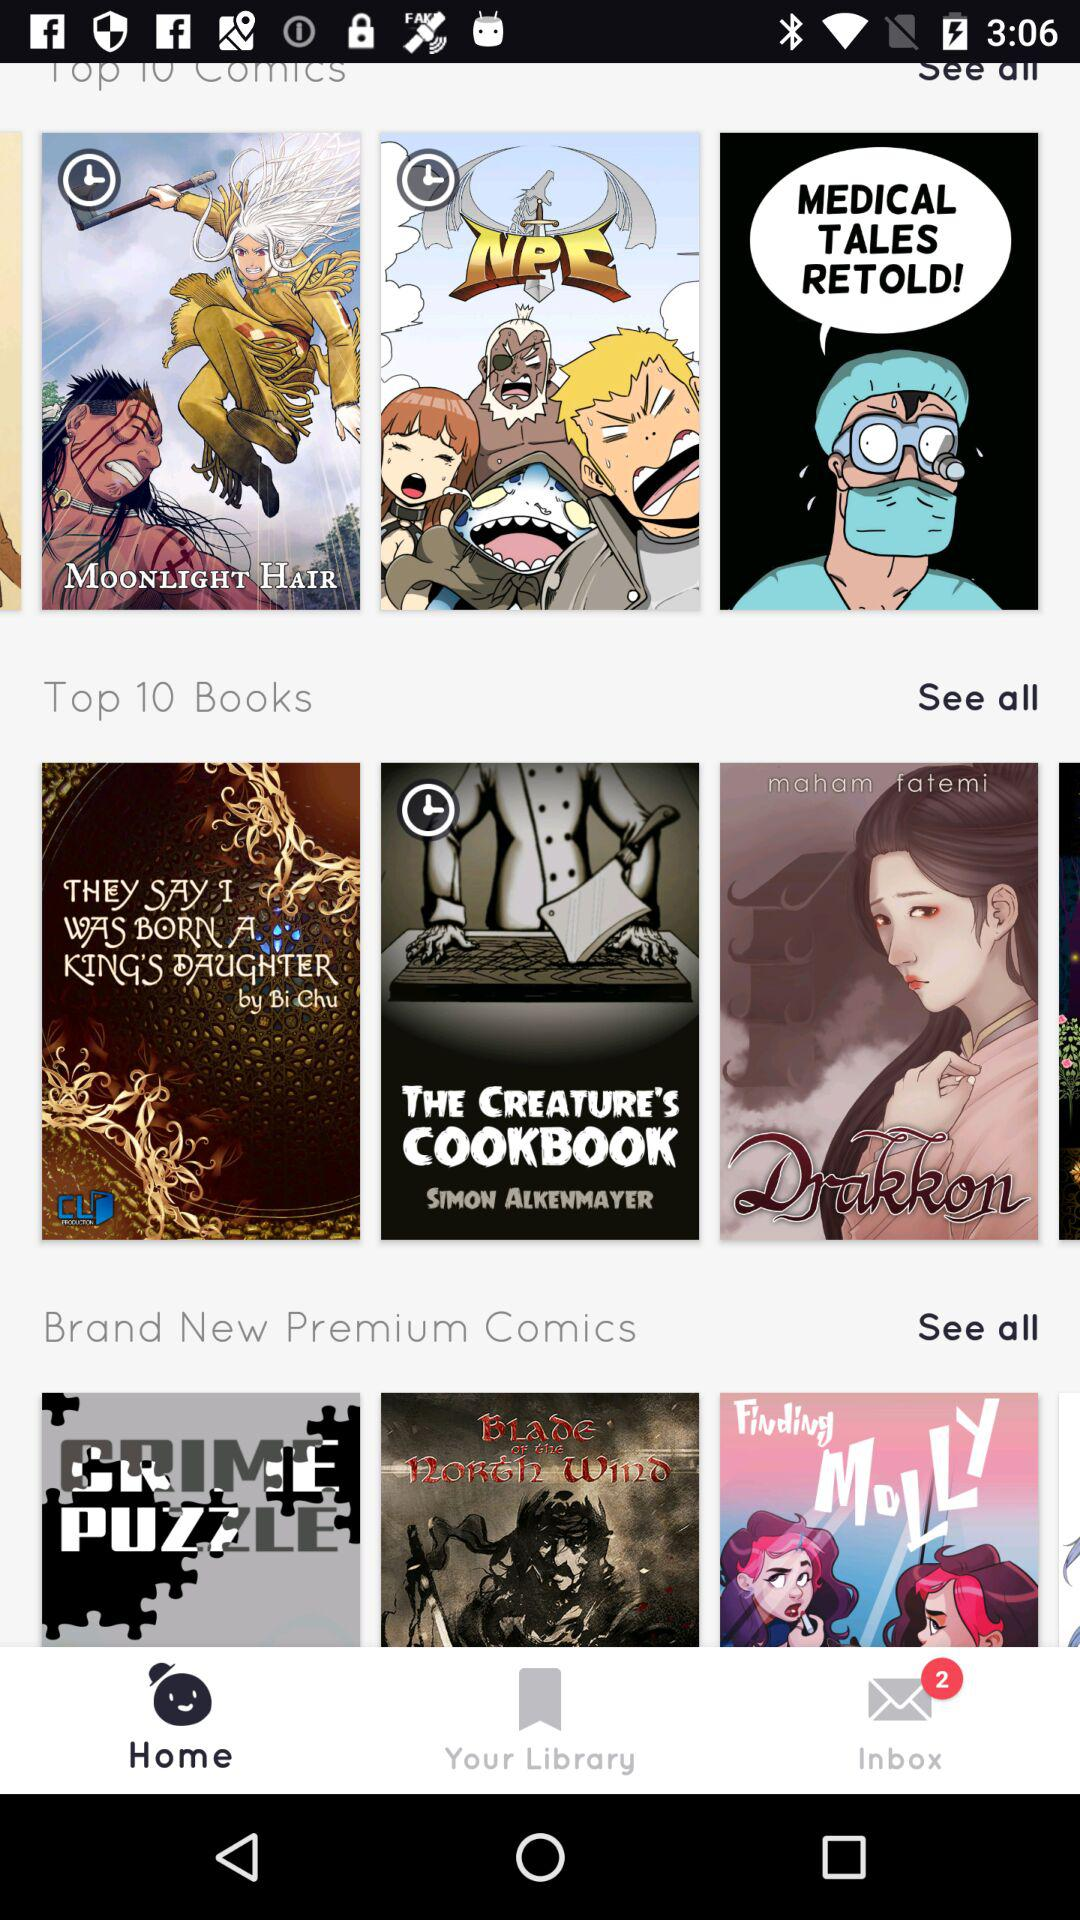What are the top 10 books? The top 10 books are "THEY SAY I WAS BORN A KING'S DAUGHTER", "THE CREATURE'S COOKBOOK" and "Drakkon". 